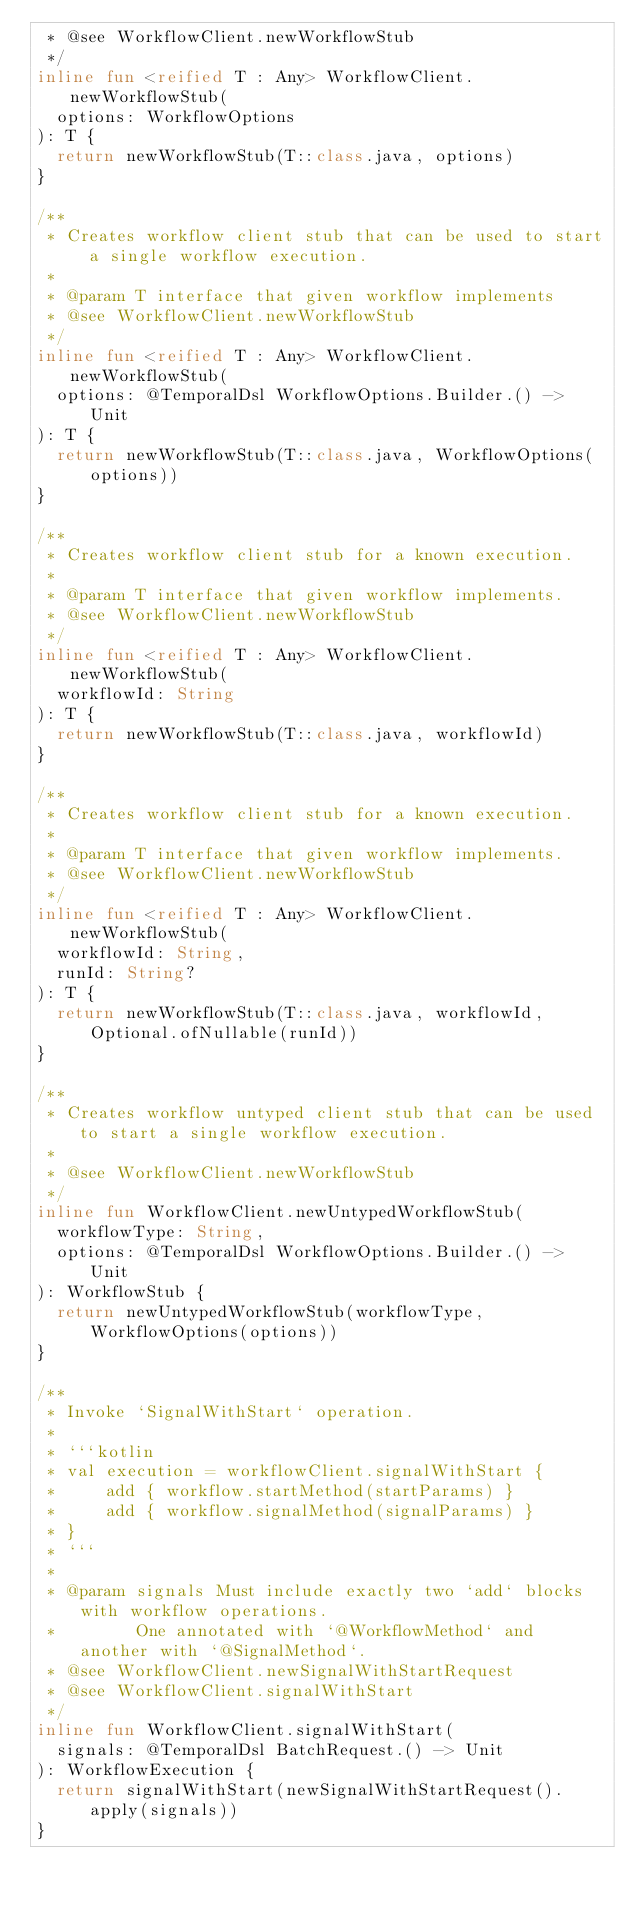Convert code to text. <code><loc_0><loc_0><loc_500><loc_500><_Kotlin_> * @see WorkflowClient.newWorkflowStub
 */
inline fun <reified T : Any> WorkflowClient.newWorkflowStub(
  options: WorkflowOptions
): T {
  return newWorkflowStub(T::class.java, options)
}

/**
 * Creates workflow client stub that can be used to start a single workflow execution.
 *
 * @param T interface that given workflow implements
 * @see WorkflowClient.newWorkflowStub
 */
inline fun <reified T : Any> WorkflowClient.newWorkflowStub(
  options: @TemporalDsl WorkflowOptions.Builder.() -> Unit
): T {
  return newWorkflowStub(T::class.java, WorkflowOptions(options))
}

/**
 * Creates workflow client stub for a known execution.
 *
 * @param T interface that given workflow implements.
 * @see WorkflowClient.newWorkflowStub
 */
inline fun <reified T : Any> WorkflowClient.newWorkflowStub(
  workflowId: String
): T {
  return newWorkflowStub(T::class.java, workflowId)
}

/**
 * Creates workflow client stub for a known execution.
 *
 * @param T interface that given workflow implements.
 * @see WorkflowClient.newWorkflowStub
 */
inline fun <reified T : Any> WorkflowClient.newWorkflowStub(
  workflowId: String,
  runId: String?
): T {
  return newWorkflowStub(T::class.java, workflowId, Optional.ofNullable(runId))
}

/**
 * Creates workflow untyped client stub that can be used to start a single workflow execution.
 *
 * @see WorkflowClient.newWorkflowStub
 */
inline fun WorkflowClient.newUntypedWorkflowStub(
  workflowType: String,
  options: @TemporalDsl WorkflowOptions.Builder.() -> Unit
): WorkflowStub {
  return newUntypedWorkflowStub(workflowType, WorkflowOptions(options))
}

/**
 * Invoke `SignalWithStart` operation.
 *
 * ```kotlin
 * val execution = workflowClient.signalWithStart {
 *     add { workflow.startMethod(startParams) }
 *     add { workflow.signalMethod(signalParams) }
 * }
 * ```
 *
 * @param signals Must include exactly two `add` blocks with workflow operations.
 *        One annotated with `@WorkflowMethod` and another with `@SignalMethod`.
 * @see WorkflowClient.newSignalWithStartRequest
 * @see WorkflowClient.signalWithStart
 */
inline fun WorkflowClient.signalWithStart(
  signals: @TemporalDsl BatchRequest.() -> Unit
): WorkflowExecution {
  return signalWithStart(newSignalWithStartRequest().apply(signals))
}
</code> 